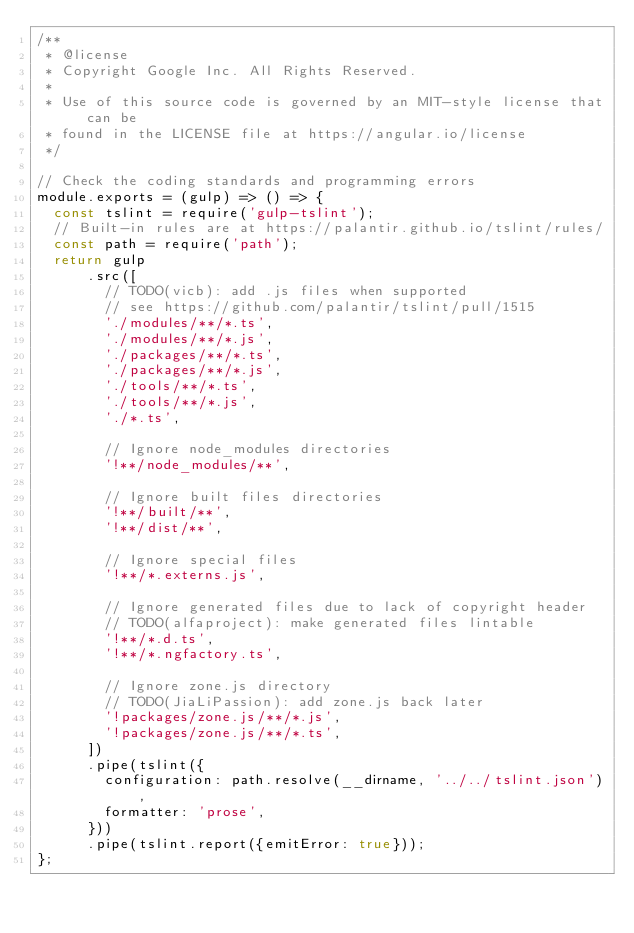<code> <loc_0><loc_0><loc_500><loc_500><_JavaScript_>/**
 * @license
 * Copyright Google Inc. All Rights Reserved.
 *
 * Use of this source code is governed by an MIT-style license that can be
 * found in the LICENSE file at https://angular.io/license
 */

// Check the coding standards and programming errors
module.exports = (gulp) => () => {
  const tslint = require('gulp-tslint');
  // Built-in rules are at https://palantir.github.io/tslint/rules/
  const path = require('path');
  return gulp
      .src([
        // TODO(vicb): add .js files when supported
        // see https://github.com/palantir/tslint/pull/1515
        './modules/**/*.ts',
        './modules/**/*.js',
        './packages/**/*.ts',
        './packages/**/*.js',
        './tools/**/*.ts',
        './tools/**/*.js',
        './*.ts',

        // Ignore node_modules directories
        '!**/node_modules/**',

        // Ignore built files directories
        '!**/built/**',
        '!**/dist/**',

        // Ignore special files
        '!**/*.externs.js',

        // Ignore generated files due to lack of copyright header
        // TODO(alfaproject): make generated files lintable
        '!**/*.d.ts',
        '!**/*.ngfactory.ts',

        // Ignore zone.js directory
        // TODO(JiaLiPassion): add zone.js back later
        '!packages/zone.js/**/*.js',
        '!packages/zone.js/**/*.ts',
      ])
      .pipe(tslint({
        configuration: path.resolve(__dirname, '../../tslint.json'),
        formatter: 'prose',
      }))
      .pipe(tslint.report({emitError: true}));
};
</code> 